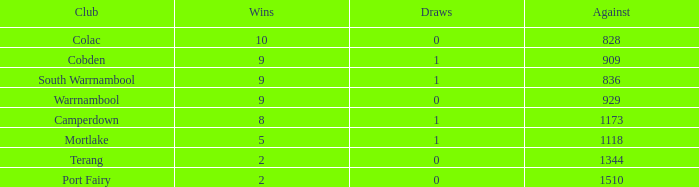When the opposing team scores fewer than 1510 points, what is port fairy's total win count? None. 